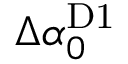<formula> <loc_0><loc_0><loc_500><loc_500>\Delta \alpha _ { 0 } ^ { D 1 }</formula> 